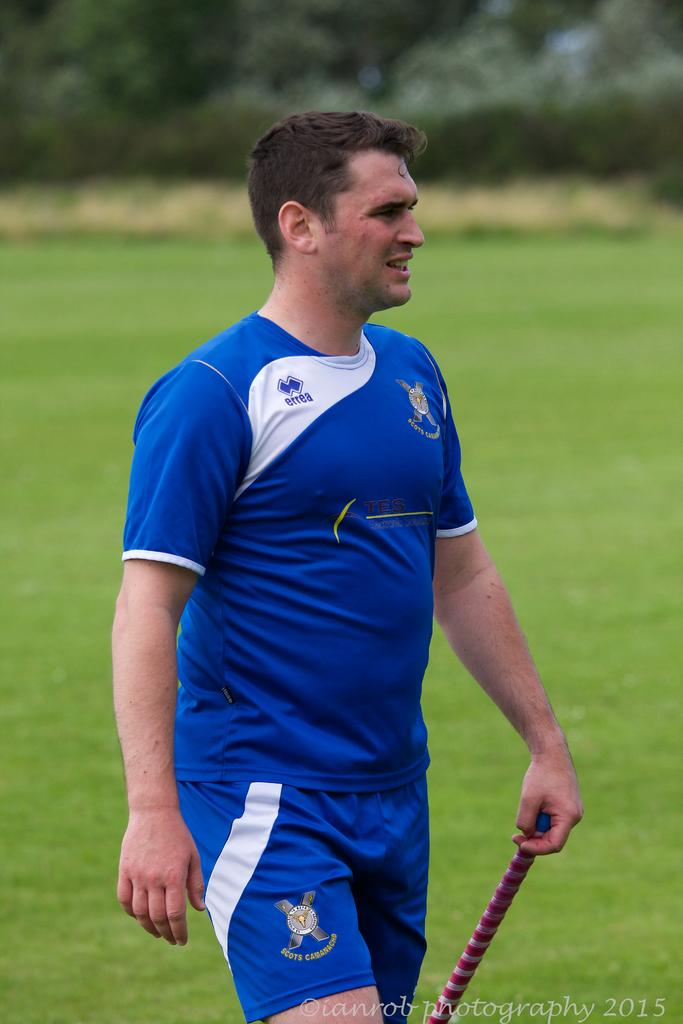What is present in the image? There is a man in the image. Can you describe the background of the man? The background of the man is blurred. What type of laborer is depicted in the image? There is no laborer present in the image; it only features a man. How many people are in the middle of the image? There is no information about the number of people in the middle of the image, as the man is the only person present. 